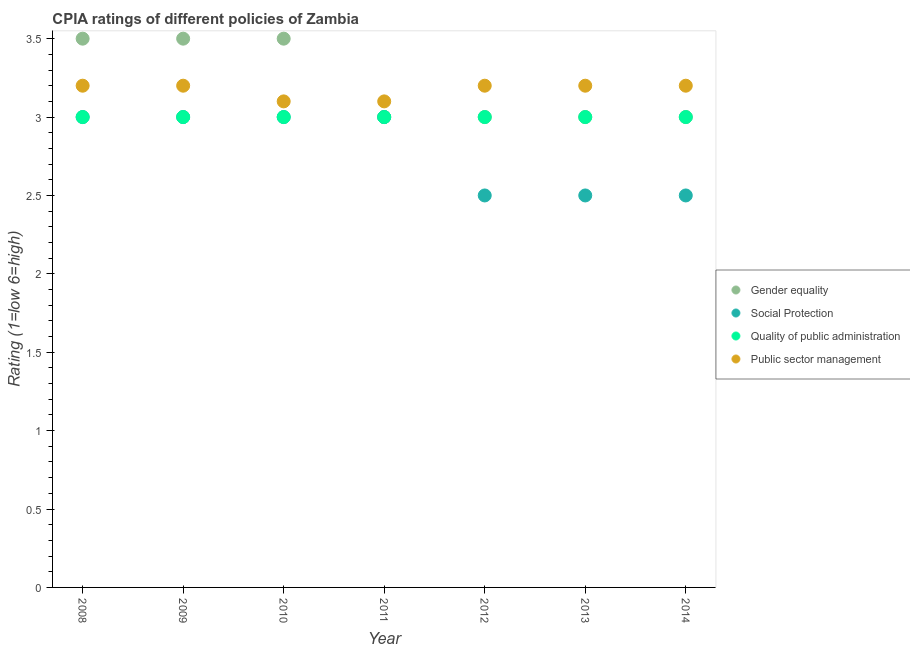How many different coloured dotlines are there?
Keep it short and to the point. 4. Is the number of dotlines equal to the number of legend labels?
Ensure brevity in your answer.  Yes. In which year was the cpia rating of gender equality maximum?
Give a very brief answer. 2008. In which year was the cpia rating of gender equality minimum?
Provide a short and direct response. 2011. What is the total cpia rating of quality of public administration in the graph?
Provide a succinct answer. 21. What is the difference between the cpia rating of public sector management in 2009 and that in 2011?
Keep it short and to the point. 0.1. What is the difference between the cpia rating of public sector management in 2013 and the cpia rating of social protection in 2009?
Your answer should be very brief. 0.2. What is the average cpia rating of public sector management per year?
Keep it short and to the point. 3.17. In the year 2013, what is the difference between the cpia rating of quality of public administration and cpia rating of public sector management?
Provide a short and direct response. -0.2. What is the ratio of the cpia rating of quality of public administration in 2009 to that in 2010?
Ensure brevity in your answer.  1. What is the difference between the highest and the second highest cpia rating of public sector management?
Provide a succinct answer. 0. Is it the case that in every year, the sum of the cpia rating of gender equality and cpia rating of social protection is greater than the cpia rating of quality of public administration?
Provide a short and direct response. Yes. Is the cpia rating of quality of public administration strictly greater than the cpia rating of social protection over the years?
Ensure brevity in your answer.  No. How many dotlines are there?
Offer a terse response. 4. Are the values on the major ticks of Y-axis written in scientific E-notation?
Make the answer very short. No. Does the graph contain grids?
Give a very brief answer. No. How many legend labels are there?
Keep it short and to the point. 4. How are the legend labels stacked?
Your response must be concise. Vertical. What is the title of the graph?
Offer a terse response. CPIA ratings of different policies of Zambia. What is the label or title of the X-axis?
Your answer should be very brief. Year. What is the label or title of the Y-axis?
Your answer should be very brief. Rating (1=low 6=high). What is the Rating (1=low 6=high) in Gender equality in 2008?
Provide a succinct answer. 3.5. What is the Rating (1=low 6=high) of Gender equality in 2009?
Provide a short and direct response. 3.5. What is the Rating (1=low 6=high) in Social Protection in 2009?
Provide a short and direct response. 3. What is the Rating (1=low 6=high) in Quality of public administration in 2009?
Your answer should be compact. 3. What is the Rating (1=low 6=high) in Gender equality in 2010?
Your answer should be compact. 3.5. What is the Rating (1=low 6=high) of Social Protection in 2010?
Make the answer very short. 3. What is the Rating (1=low 6=high) of Quality of public administration in 2010?
Offer a very short reply. 3. What is the Rating (1=low 6=high) in Public sector management in 2010?
Offer a very short reply. 3.1. What is the Rating (1=low 6=high) of Quality of public administration in 2012?
Keep it short and to the point. 3. What is the Rating (1=low 6=high) of Gender equality in 2013?
Ensure brevity in your answer.  3. What is the Rating (1=low 6=high) of Social Protection in 2013?
Make the answer very short. 2.5. What is the Rating (1=low 6=high) in Public sector management in 2013?
Give a very brief answer. 3.2. What is the Rating (1=low 6=high) of Quality of public administration in 2014?
Give a very brief answer. 3. Across all years, what is the minimum Rating (1=low 6=high) in Social Protection?
Ensure brevity in your answer.  2.5. Across all years, what is the minimum Rating (1=low 6=high) of Public sector management?
Your response must be concise. 3.1. What is the total Rating (1=low 6=high) in Gender equality in the graph?
Ensure brevity in your answer.  22.5. What is the total Rating (1=low 6=high) in Social Protection in the graph?
Offer a terse response. 19.5. What is the total Rating (1=low 6=high) in Quality of public administration in the graph?
Make the answer very short. 21. What is the difference between the Rating (1=low 6=high) of Social Protection in 2008 and that in 2009?
Make the answer very short. 0. What is the difference between the Rating (1=low 6=high) of Social Protection in 2008 and that in 2010?
Ensure brevity in your answer.  0. What is the difference between the Rating (1=low 6=high) of Quality of public administration in 2008 and that in 2010?
Your answer should be compact. 0. What is the difference between the Rating (1=low 6=high) of Gender equality in 2008 and that in 2011?
Your response must be concise. 0.5. What is the difference between the Rating (1=low 6=high) in Public sector management in 2008 and that in 2011?
Give a very brief answer. 0.1. What is the difference between the Rating (1=low 6=high) of Public sector management in 2008 and that in 2012?
Provide a short and direct response. 0. What is the difference between the Rating (1=low 6=high) in Quality of public administration in 2008 and that in 2013?
Offer a terse response. 0. What is the difference between the Rating (1=low 6=high) of Social Protection in 2008 and that in 2014?
Provide a short and direct response. 0.5. What is the difference between the Rating (1=low 6=high) of Quality of public administration in 2009 and that in 2010?
Give a very brief answer. 0. What is the difference between the Rating (1=low 6=high) in Public sector management in 2009 and that in 2010?
Give a very brief answer. 0.1. What is the difference between the Rating (1=low 6=high) of Gender equality in 2009 and that in 2011?
Give a very brief answer. 0.5. What is the difference between the Rating (1=low 6=high) of Quality of public administration in 2009 and that in 2011?
Give a very brief answer. 0. What is the difference between the Rating (1=low 6=high) of Public sector management in 2009 and that in 2011?
Provide a succinct answer. 0.1. What is the difference between the Rating (1=low 6=high) in Public sector management in 2009 and that in 2012?
Your answer should be very brief. 0. What is the difference between the Rating (1=low 6=high) in Gender equality in 2009 and that in 2013?
Offer a terse response. 0.5. What is the difference between the Rating (1=low 6=high) in Social Protection in 2009 and that in 2013?
Your answer should be very brief. 0.5. What is the difference between the Rating (1=low 6=high) of Quality of public administration in 2009 and that in 2013?
Your answer should be very brief. 0. What is the difference between the Rating (1=low 6=high) of Gender equality in 2009 and that in 2014?
Ensure brevity in your answer.  0.5. What is the difference between the Rating (1=low 6=high) in Quality of public administration in 2009 and that in 2014?
Your answer should be very brief. 0. What is the difference between the Rating (1=low 6=high) in Quality of public administration in 2010 and that in 2011?
Give a very brief answer. 0. What is the difference between the Rating (1=low 6=high) in Quality of public administration in 2010 and that in 2012?
Your response must be concise. 0. What is the difference between the Rating (1=low 6=high) in Public sector management in 2010 and that in 2012?
Provide a short and direct response. -0.1. What is the difference between the Rating (1=low 6=high) in Gender equality in 2010 and that in 2013?
Ensure brevity in your answer.  0.5. What is the difference between the Rating (1=low 6=high) of Social Protection in 2010 and that in 2013?
Your answer should be very brief. 0.5. What is the difference between the Rating (1=low 6=high) in Quality of public administration in 2010 and that in 2013?
Offer a very short reply. 0. What is the difference between the Rating (1=low 6=high) of Social Protection in 2010 and that in 2014?
Your answer should be very brief. 0.5. What is the difference between the Rating (1=low 6=high) in Quality of public administration in 2010 and that in 2014?
Provide a succinct answer. 0. What is the difference between the Rating (1=low 6=high) in Quality of public administration in 2011 and that in 2012?
Provide a short and direct response. 0. What is the difference between the Rating (1=low 6=high) of Public sector management in 2011 and that in 2012?
Keep it short and to the point. -0.1. What is the difference between the Rating (1=low 6=high) in Gender equality in 2011 and that in 2013?
Give a very brief answer. 0. What is the difference between the Rating (1=low 6=high) of Social Protection in 2011 and that in 2013?
Ensure brevity in your answer.  0.5. What is the difference between the Rating (1=low 6=high) of Quality of public administration in 2011 and that in 2013?
Your response must be concise. 0. What is the difference between the Rating (1=low 6=high) in Quality of public administration in 2011 and that in 2014?
Ensure brevity in your answer.  0. What is the difference between the Rating (1=low 6=high) in Public sector management in 2011 and that in 2014?
Provide a short and direct response. -0.1. What is the difference between the Rating (1=low 6=high) in Quality of public administration in 2012 and that in 2013?
Offer a very short reply. 0. What is the difference between the Rating (1=low 6=high) of Social Protection in 2012 and that in 2014?
Provide a succinct answer. 0. What is the difference between the Rating (1=low 6=high) in Public sector management in 2012 and that in 2014?
Offer a terse response. 0. What is the difference between the Rating (1=low 6=high) of Gender equality in 2013 and that in 2014?
Make the answer very short. 0. What is the difference between the Rating (1=low 6=high) of Public sector management in 2013 and that in 2014?
Offer a terse response. 0. What is the difference between the Rating (1=low 6=high) of Gender equality in 2008 and the Rating (1=low 6=high) of Quality of public administration in 2009?
Offer a very short reply. 0.5. What is the difference between the Rating (1=low 6=high) in Gender equality in 2008 and the Rating (1=low 6=high) in Public sector management in 2009?
Offer a terse response. 0.3. What is the difference between the Rating (1=low 6=high) of Gender equality in 2008 and the Rating (1=low 6=high) of Public sector management in 2010?
Ensure brevity in your answer.  0.4. What is the difference between the Rating (1=low 6=high) of Social Protection in 2008 and the Rating (1=low 6=high) of Public sector management in 2010?
Your answer should be compact. -0.1. What is the difference between the Rating (1=low 6=high) in Gender equality in 2008 and the Rating (1=low 6=high) in Public sector management in 2011?
Your response must be concise. 0.4. What is the difference between the Rating (1=low 6=high) of Social Protection in 2008 and the Rating (1=low 6=high) of Public sector management in 2011?
Your answer should be very brief. -0.1. What is the difference between the Rating (1=low 6=high) in Quality of public administration in 2008 and the Rating (1=low 6=high) in Public sector management in 2011?
Provide a succinct answer. -0.1. What is the difference between the Rating (1=low 6=high) of Gender equality in 2008 and the Rating (1=low 6=high) of Social Protection in 2012?
Your answer should be very brief. 1. What is the difference between the Rating (1=low 6=high) of Gender equality in 2008 and the Rating (1=low 6=high) of Quality of public administration in 2012?
Your response must be concise. 0.5. What is the difference between the Rating (1=low 6=high) in Gender equality in 2008 and the Rating (1=low 6=high) in Public sector management in 2012?
Ensure brevity in your answer.  0.3. What is the difference between the Rating (1=low 6=high) of Social Protection in 2008 and the Rating (1=low 6=high) of Quality of public administration in 2012?
Your answer should be compact. 0. What is the difference between the Rating (1=low 6=high) in Social Protection in 2008 and the Rating (1=low 6=high) in Public sector management in 2012?
Provide a short and direct response. -0.2. What is the difference between the Rating (1=low 6=high) of Gender equality in 2008 and the Rating (1=low 6=high) of Quality of public administration in 2013?
Your response must be concise. 0.5. What is the difference between the Rating (1=low 6=high) of Social Protection in 2008 and the Rating (1=low 6=high) of Quality of public administration in 2013?
Keep it short and to the point. 0. What is the difference between the Rating (1=low 6=high) of Gender equality in 2008 and the Rating (1=low 6=high) of Public sector management in 2014?
Your answer should be compact. 0.3. What is the difference between the Rating (1=low 6=high) of Gender equality in 2009 and the Rating (1=low 6=high) of Social Protection in 2010?
Provide a short and direct response. 0.5. What is the difference between the Rating (1=low 6=high) of Gender equality in 2009 and the Rating (1=low 6=high) of Quality of public administration in 2010?
Give a very brief answer. 0.5. What is the difference between the Rating (1=low 6=high) of Gender equality in 2009 and the Rating (1=low 6=high) of Quality of public administration in 2011?
Your answer should be very brief. 0.5. What is the difference between the Rating (1=low 6=high) of Gender equality in 2009 and the Rating (1=low 6=high) of Public sector management in 2011?
Your response must be concise. 0.4. What is the difference between the Rating (1=low 6=high) of Social Protection in 2009 and the Rating (1=low 6=high) of Public sector management in 2011?
Your response must be concise. -0.1. What is the difference between the Rating (1=low 6=high) in Quality of public administration in 2009 and the Rating (1=low 6=high) in Public sector management in 2011?
Your answer should be compact. -0.1. What is the difference between the Rating (1=low 6=high) of Gender equality in 2009 and the Rating (1=low 6=high) of Quality of public administration in 2012?
Make the answer very short. 0.5. What is the difference between the Rating (1=low 6=high) in Gender equality in 2009 and the Rating (1=low 6=high) in Public sector management in 2012?
Offer a terse response. 0.3. What is the difference between the Rating (1=low 6=high) of Social Protection in 2009 and the Rating (1=low 6=high) of Public sector management in 2012?
Make the answer very short. -0.2. What is the difference between the Rating (1=low 6=high) in Quality of public administration in 2009 and the Rating (1=low 6=high) in Public sector management in 2012?
Provide a succinct answer. -0.2. What is the difference between the Rating (1=low 6=high) in Gender equality in 2009 and the Rating (1=low 6=high) in Social Protection in 2013?
Offer a very short reply. 1. What is the difference between the Rating (1=low 6=high) in Gender equality in 2009 and the Rating (1=low 6=high) in Public sector management in 2013?
Offer a very short reply. 0.3. What is the difference between the Rating (1=low 6=high) of Social Protection in 2009 and the Rating (1=low 6=high) of Quality of public administration in 2013?
Give a very brief answer. 0. What is the difference between the Rating (1=low 6=high) of Social Protection in 2009 and the Rating (1=low 6=high) of Public sector management in 2013?
Offer a very short reply. -0.2. What is the difference between the Rating (1=low 6=high) in Quality of public administration in 2009 and the Rating (1=low 6=high) in Public sector management in 2013?
Provide a short and direct response. -0.2. What is the difference between the Rating (1=low 6=high) in Gender equality in 2009 and the Rating (1=low 6=high) in Social Protection in 2014?
Keep it short and to the point. 1. What is the difference between the Rating (1=low 6=high) of Gender equality in 2009 and the Rating (1=low 6=high) of Quality of public administration in 2014?
Make the answer very short. 0.5. What is the difference between the Rating (1=low 6=high) of Gender equality in 2009 and the Rating (1=low 6=high) of Public sector management in 2014?
Keep it short and to the point. 0.3. What is the difference between the Rating (1=low 6=high) in Social Protection in 2009 and the Rating (1=low 6=high) in Public sector management in 2014?
Your answer should be very brief. -0.2. What is the difference between the Rating (1=low 6=high) in Social Protection in 2010 and the Rating (1=low 6=high) in Quality of public administration in 2011?
Give a very brief answer. 0. What is the difference between the Rating (1=low 6=high) in Quality of public administration in 2010 and the Rating (1=low 6=high) in Public sector management in 2011?
Give a very brief answer. -0.1. What is the difference between the Rating (1=low 6=high) in Gender equality in 2010 and the Rating (1=low 6=high) in Quality of public administration in 2012?
Your answer should be very brief. 0.5. What is the difference between the Rating (1=low 6=high) in Gender equality in 2010 and the Rating (1=low 6=high) in Public sector management in 2012?
Your response must be concise. 0.3. What is the difference between the Rating (1=low 6=high) in Social Protection in 2010 and the Rating (1=low 6=high) in Public sector management in 2013?
Ensure brevity in your answer.  -0.2. What is the difference between the Rating (1=low 6=high) of Quality of public administration in 2010 and the Rating (1=low 6=high) of Public sector management in 2013?
Ensure brevity in your answer.  -0.2. What is the difference between the Rating (1=low 6=high) of Gender equality in 2010 and the Rating (1=low 6=high) of Social Protection in 2014?
Provide a succinct answer. 1. What is the difference between the Rating (1=low 6=high) of Gender equality in 2010 and the Rating (1=low 6=high) of Public sector management in 2014?
Give a very brief answer. 0.3. What is the difference between the Rating (1=low 6=high) in Social Protection in 2010 and the Rating (1=low 6=high) in Quality of public administration in 2014?
Ensure brevity in your answer.  0. What is the difference between the Rating (1=low 6=high) in Gender equality in 2011 and the Rating (1=low 6=high) in Social Protection in 2012?
Offer a very short reply. 0.5. What is the difference between the Rating (1=low 6=high) in Social Protection in 2011 and the Rating (1=low 6=high) in Quality of public administration in 2012?
Your answer should be very brief. 0. What is the difference between the Rating (1=low 6=high) in Quality of public administration in 2011 and the Rating (1=low 6=high) in Public sector management in 2012?
Make the answer very short. -0.2. What is the difference between the Rating (1=low 6=high) of Gender equality in 2011 and the Rating (1=low 6=high) of Social Protection in 2013?
Your answer should be very brief. 0.5. What is the difference between the Rating (1=low 6=high) of Gender equality in 2011 and the Rating (1=low 6=high) of Public sector management in 2013?
Give a very brief answer. -0.2. What is the difference between the Rating (1=low 6=high) of Social Protection in 2011 and the Rating (1=low 6=high) of Public sector management in 2013?
Offer a terse response. -0.2. What is the difference between the Rating (1=low 6=high) in Quality of public administration in 2011 and the Rating (1=low 6=high) in Public sector management in 2013?
Keep it short and to the point. -0.2. What is the difference between the Rating (1=low 6=high) in Gender equality in 2011 and the Rating (1=low 6=high) in Social Protection in 2014?
Make the answer very short. 0.5. What is the difference between the Rating (1=low 6=high) in Gender equality in 2011 and the Rating (1=low 6=high) in Public sector management in 2014?
Provide a succinct answer. -0.2. What is the difference between the Rating (1=low 6=high) in Social Protection in 2011 and the Rating (1=low 6=high) in Public sector management in 2014?
Provide a short and direct response. -0.2. What is the difference between the Rating (1=low 6=high) in Gender equality in 2012 and the Rating (1=low 6=high) in Social Protection in 2013?
Your response must be concise. 0.5. What is the difference between the Rating (1=low 6=high) of Gender equality in 2012 and the Rating (1=low 6=high) of Public sector management in 2013?
Your response must be concise. -0.2. What is the difference between the Rating (1=low 6=high) in Quality of public administration in 2012 and the Rating (1=low 6=high) in Public sector management in 2013?
Your answer should be compact. -0.2. What is the difference between the Rating (1=low 6=high) of Gender equality in 2012 and the Rating (1=low 6=high) of Social Protection in 2014?
Ensure brevity in your answer.  0.5. What is the difference between the Rating (1=low 6=high) of Gender equality in 2012 and the Rating (1=low 6=high) of Public sector management in 2014?
Your response must be concise. -0.2. What is the difference between the Rating (1=low 6=high) of Social Protection in 2012 and the Rating (1=low 6=high) of Quality of public administration in 2014?
Your answer should be very brief. -0.5. What is the difference between the Rating (1=low 6=high) of Gender equality in 2013 and the Rating (1=low 6=high) of Social Protection in 2014?
Your response must be concise. 0.5. What is the difference between the Rating (1=low 6=high) of Gender equality in 2013 and the Rating (1=low 6=high) of Quality of public administration in 2014?
Your response must be concise. 0. What is the difference between the Rating (1=low 6=high) of Gender equality in 2013 and the Rating (1=low 6=high) of Public sector management in 2014?
Your answer should be very brief. -0.2. What is the average Rating (1=low 6=high) of Gender equality per year?
Offer a very short reply. 3.21. What is the average Rating (1=low 6=high) in Social Protection per year?
Your answer should be compact. 2.79. What is the average Rating (1=low 6=high) of Public sector management per year?
Your answer should be very brief. 3.17. In the year 2008, what is the difference between the Rating (1=low 6=high) of Gender equality and Rating (1=low 6=high) of Social Protection?
Your answer should be very brief. 0.5. In the year 2008, what is the difference between the Rating (1=low 6=high) in Gender equality and Rating (1=low 6=high) in Quality of public administration?
Make the answer very short. 0.5. In the year 2008, what is the difference between the Rating (1=low 6=high) of Gender equality and Rating (1=low 6=high) of Public sector management?
Ensure brevity in your answer.  0.3. In the year 2008, what is the difference between the Rating (1=low 6=high) of Social Protection and Rating (1=low 6=high) of Public sector management?
Your answer should be very brief. -0.2. In the year 2008, what is the difference between the Rating (1=low 6=high) of Quality of public administration and Rating (1=low 6=high) of Public sector management?
Your answer should be very brief. -0.2. In the year 2009, what is the difference between the Rating (1=low 6=high) in Gender equality and Rating (1=low 6=high) in Quality of public administration?
Make the answer very short. 0.5. In the year 2009, what is the difference between the Rating (1=low 6=high) in Quality of public administration and Rating (1=low 6=high) in Public sector management?
Your answer should be compact. -0.2. In the year 2010, what is the difference between the Rating (1=low 6=high) in Gender equality and Rating (1=low 6=high) in Social Protection?
Give a very brief answer. 0.5. In the year 2010, what is the difference between the Rating (1=low 6=high) in Gender equality and Rating (1=low 6=high) in Quality of public administration?
Provide a succinct answer. 0.5. In the year 2010, what is the difference between the Rating (1=low 6=high) in Gender equality and Rating (1=low 6=high) in Public sector management?
Your response must be concise. 0.4. In the year 2011, what is the difference between the Rating (1=low 6=high) of Gender equality and Rating (1=low 6=high) of Social Protection?
Your answer should be very brief. 0. In the year 2011, what is the difference between the Rating (1=low 6=high) in Gender equality and Rating (1=low 6=high) in Public sector management?
Offer a terse response. -0.1. In the year 2011, what is the difference between the Rating (1=low 6=high) of Social Protection and Rating (1=low 6=high) of Quality of public administration?
Offer a terse response. 0. In the year 2011, what is the difference between the Rating (1=low 6=high) of Social Protection and Rating (1=low 6=high) of Public sector management?
Give a very brief answer. -0.1. In the year 2012, what is the difference between the Rating (1=low 6=high) of Gender equality and Rating (1=low 6=high) of Social Protection?
Keep it short and to the point. 0.5. In the year 2012, what is the difference between the Rating (1=low 6=high) of Gender equality and Rating (1=low 6=high) of Public sector management?
Your answer should be very brief. -0.2. In the year 2012, what is the difference between the Rating (1=low 6=high) of Quality of public administration and Rating (1=low 6=high) of Public sector management?
Keep it short and to the point. -0.2. In the year 2013, what is the difference between the Rating (1=low 6=high) in Gender equality and Rating (1=low 6=high) in Social Protection?
Make the answer very short. 0.5. In the year 2013, what is the difference between the Rating (1=low 6=high) of Social Protection and Rating (1=low 6=high) of Public sector management?
Offer a terse response. -0.7. In the year 2013, what is the difference between the Rating (1=low 6=high) of Quality of public administration and Rating (1=low 6=high) of Public sector management?
Give a very brief answer. -0.2. What is the ratio of the Rating (1=low 6=high) in Quality of public administration in 2008 to that in 2009?
Your answer should be compact. 1. What is the ratio of the Rating (1=low 6=high) of Social Protection in 2008 to that in 2010?
Ensure brevity in your answer.  1. What is the ratio of the Rating (1=low 6=high) in Quality of public administration in 2008 to that in 2010?
Make the answer very short. 1. What is the ratio of the Rating (1=low 6=high) in Public sector management in 2008 to that in 2010?
Your response must be concise. 1.03. What is the ratio of the Rating (1=low 6=high) in Gender equality in 2008 to that in 2011?
Give a very brief answer. 1.17. What is the ratio of the Rating (1=low 6=high) in Public sector management in 2008 to that in 2011?
Ensure brevity in your answer.  1.03. What is the ratio of the Rating (1=low 6=high) in Gender equality in 2008 to that in 2012?
Your answer should be very brief. 1.17. What is the ratio of the Rating (1=low 6=high) in Social Protection in 2008 to that in 2012?
Provide a succinct answer. 1.2. What is the ratio of the Rating (1=low 6=high) in Public sector management in 2008 to that in 2012?
Your response must be concise. 1. What is the ratio of the Rating (1=low 6=high) in Gender equality in 2008 to that in 2013?
Your answer should be very brief. 1.17. What is the ratio of the Rating (1=low 6=high) of Social Protection in 2008 to that in 2013?
Offer a terse response. 1.2. What is the ratio of the Rating (1=low 6=high) in Quality of public administration in 2008 to that in 2013?
Your answer should be very brief. 1. What is the ratio of the Rating (1=low 6=high) in Public sector management in 2008 to that in 2013?
Offer a terse response. 1. What is the ratio of the Rating (1=low 6=high) of Quality of public administration in 2008 to that in 2014?
Ensure brevity in your answer.  1. What is the ratio of the Rating (1=low 6=high) of Quality of public administration in 2009 to that in 2010?
Offer a very short reply. 1. What is the ratio of the Rating (1=low 6=high) of Public sector management in 2009 to that in 2010?
Ensure brevity in your answer.  1.03. What is the ratio of the Rating (1=low 6=high) of Public sector management in 2009 to that in 2011?
Your response must be concise. 1.03. What is the ratio of the Rating (1=low 6=high) in Social Protection in 2009 to that in 2012?
Keep it short and to the point. 1.2. What is the ratio of the Rating (1=low 6=high) of Public sector management in 2009 to that in 2012?
Make the answer very short. 1. What is the ratio of the Rating (1=low 6=high) in Social Protection in 2009 to that in 2013?
Ensure brevity in your answer.  1.2. What is the ratio of the Rating (1=low 6=high) in Quality of public administration in 2009 to that in 2013?
Keep it short and to the point. 1. What is the ratio of the Rating (1=low 6=high) of Public sector management in 2009 to that in 2013?
Provide a short and direct response. 1. What is the ratio of the Rating (1=low 6=high) of Gender equality in 2009 to that in 2014?
Provide a short and direct response. 1.17. What is the ratio of the Rating (1=low 6=high) of Social Protection in 2010 to that in 2011?
Offer a very short reply. 1. What is the ratio of the Rating (1=low 6=high) in Gender equality in 2010 to that in 2012?
Ensure brevity in your answer.  1.17. What is the ratio of the Rating (1=low 6=high) in Social Protection in 2010 to that in 2012?
Keep it short and to the point. 1.2. What is the ratio of the Rating (1=low 6=high) of Quality of public administration in 2010 to that in 2012?
Your response must be concise. 1. What is the ratio of the Rating (1=low 6=high) in Public sector management in 2010 to that in 2012?
Keep it short and to the point. 0.97. What is the ratio of the Rating (1=low 6=high) in Quality of public administration in 2010 to that in 2013?
Your answer should be compact. 1. What is the ratio of the Rating (1=low 6=high) of Public sector management in 2010 to that in 2013?
Ensure brevity in your answer.  0.97. What is the ratio of the Rating (1=low 6=high) of Gender equality in 2010 to that in 2014?
Ensure brevity in your answer.  1.17. What is the ratio of the Rating (1=low 6=high) in Public sector management in 2010 to that in 2014?
Provide a short and direct response. 0.97. What is the ratio of the Rating (1=low 6=high) in Gender equality in 2011 to that in 2012?
Give a very brief answer. 1. What is the ratio of the Rating (1=low 6=high) of Quality of public administration in 2011 to that in 2012?
Offer a terse response. 1. What is the ratio of the Rating (1=low 6=high) in Public sector management in 2011 to that in 2012?
Your response must be concise. 0.97. What is the ratio of the Rating (1=low 6=high) in Social Protection in 2011 to that in 2013?
Your answer should be very brief. 1.2. What is the ratio of the Rating (1=low 6=high) in Public sector management in 2011 to that in 2013?
Ensure brevity in your answer.  0.97. What is the ratio of the Rating (1=low 6=high) of Gender equality in 2011 to that in 2014?
Offer a terse response. 1. What is the ratio of the Rating (1=low 6=high) of Quality of public administration in 2011 to that in 2014?
Provide a succinct answer. 1. What is the ratio of the Rating (1=low 6=high) of Public sector management in 2011 to that in 2014?
Ensure brevity in your answer.  0.97. What is the ratio of the Rating (1=low 6=high) in Gender equality in 2012 to that in 2013?
Provide a succinct answer. 1. What is the ratio of the Rating (1=low 6=high) of Social Protection in 2012 to that in 2013?
Your answer should be very brief. 1. What is the ratio of the Rating (1=low 6=high) in Public sector management in 2012 to that in 2013?
Your answer should be very brief. 1. What is the ratio of the Rating (1=low 6=high) of Gender equality in 2012 to that in 2014?
Ensure brevity in your answer.  1. What is the ratio of the Rating (1=low 6=high) in Quality of public administration in 2012 to that in 2014?
Give a very brief answer. 1. What is the ratio of the Rating (1=low 6=high) of Public sector management in 2012 to that in 2014?
Provide a short and direct response. 1. What is the ratio of the Rating (1=low 6=high) of Gender equality in 2013 to that in 2014?
Give a very brief answer. 1. What is the ratio of the Rating (1=low 6=high) in Quality of public administration in 2013 to that in 2014?
Ensure brevity in your answer.  1. What is the ratio of the Rating (1=low 6=high) of Public sector management in 2013 to that in 2014?
Provide a succinct answer. 1. What is the difference between the highest and the second highest Rating (1=low 6=high) of Quality of public administration?
Keep it short and to the point. 0. 